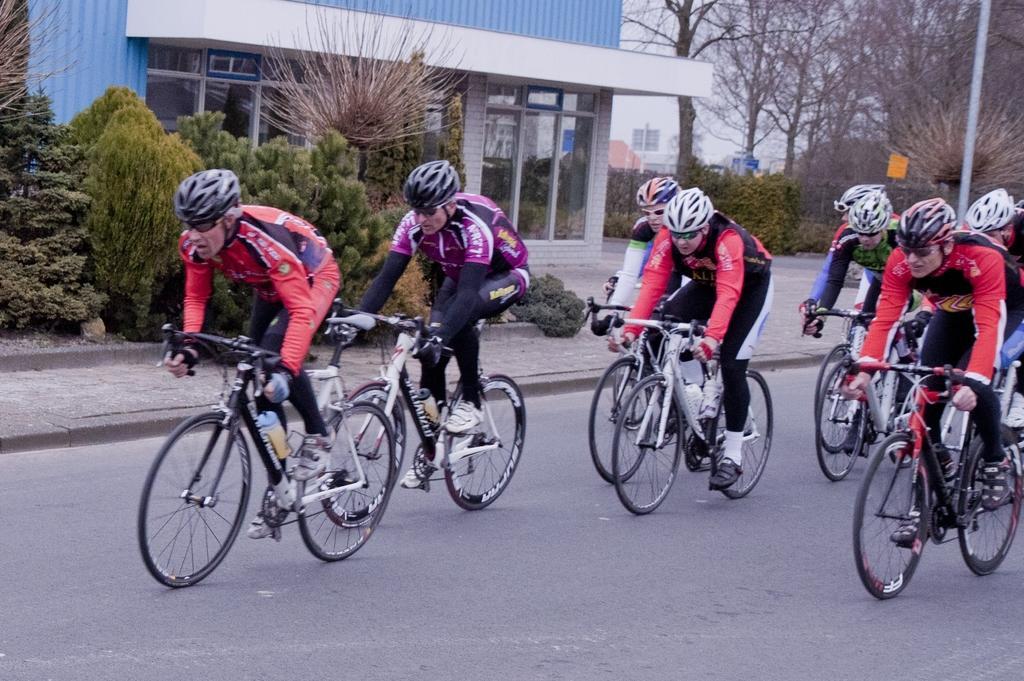Could you give a brief overview of what you see in this image? In this picture we can see a group of people wore helmets, goggles, riding bicycles on the road and in the background we can see trees, buildings, poles and some objects. 